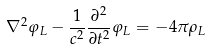Convert formula to latex. <formula><loc_0><loc_0><loc_500><loc_500>\nabla ^ { 2 } \varphi _ { L } - \frac { 1 } { c ^ { 2 } } \frac { \partial ^ { 2 } } { \partial t ^ { 2 } } \varphi _ { L } = - 4 \pi \rho _ { L }</formula> 